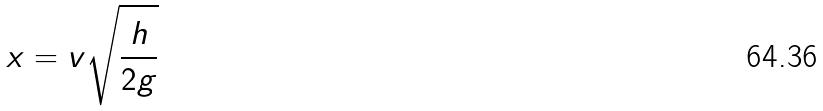<formula> <loc_0><loc_0><loc_500><loc_500>x = v \sqrt { \frac { h } { 2 g } }</formula> 